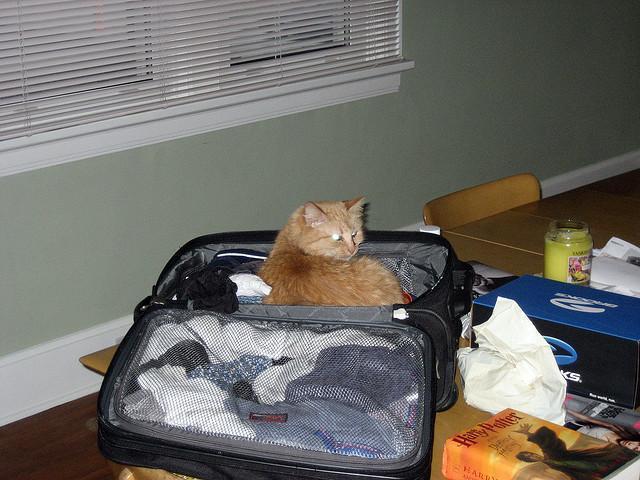How many cats are there?
Give a very brief answer. 1. 